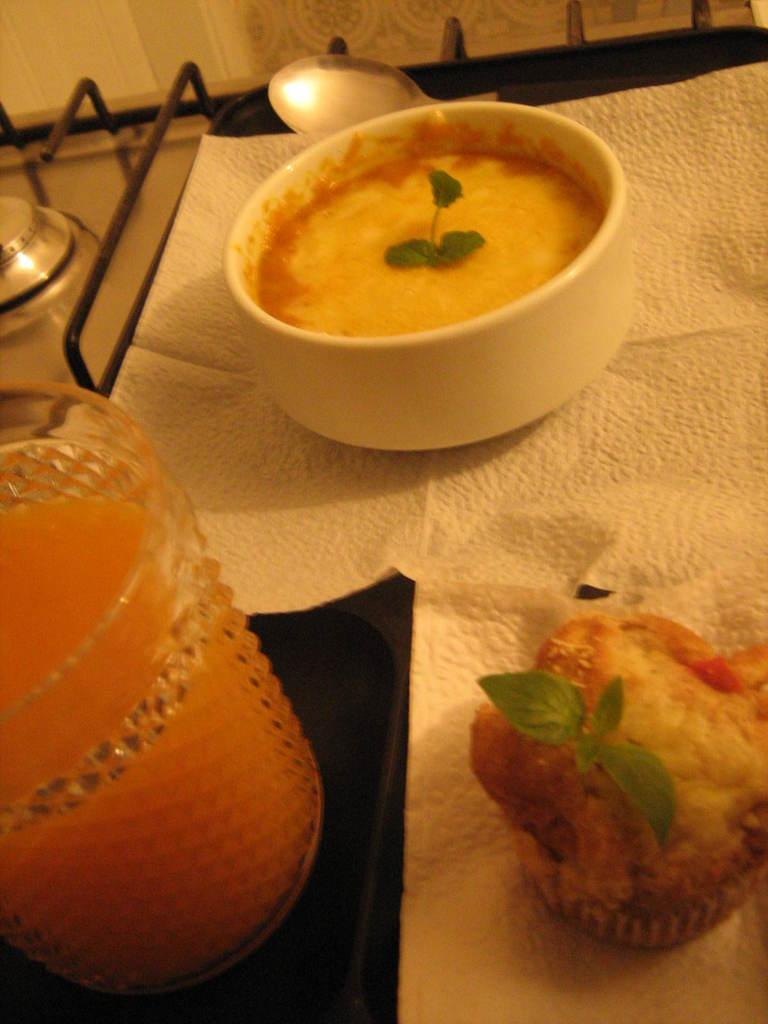What color is the bowl in the image? The bowl in the image is white. What can be seen on the left side of the image? There is a juice glass on the left side of the image. Is there a banana being approved by the fire in the image? There is no banana or fire present in the image. 